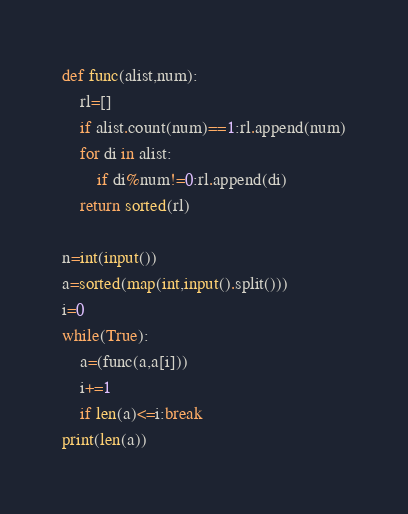<code> <loc_0><loc_0><loc_500><loc_500><_Python_>def func(alist,num):
    rl=[]
    if alist.count(num)==1:rl.append(num)
    for di in alist:
        if di%num!=0:rl.append(di)
    return sorted(rl)

n=int(input())
a=sorted(map(int,input().split()))
i=0
while(True):
    a=(func(a,a[i]))
    i+=1
    if len(a)<=i:break
print(len(a))</code> 